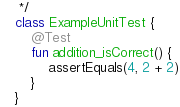<code> <loc_0><loc_0><loc_500><loc_500><_Kotlin_> */
class ExampleUnitTest {
    @Test
    fun addition_isCorrect() {
        assertEquals(4, 2 + 2)
    }
}</code> 